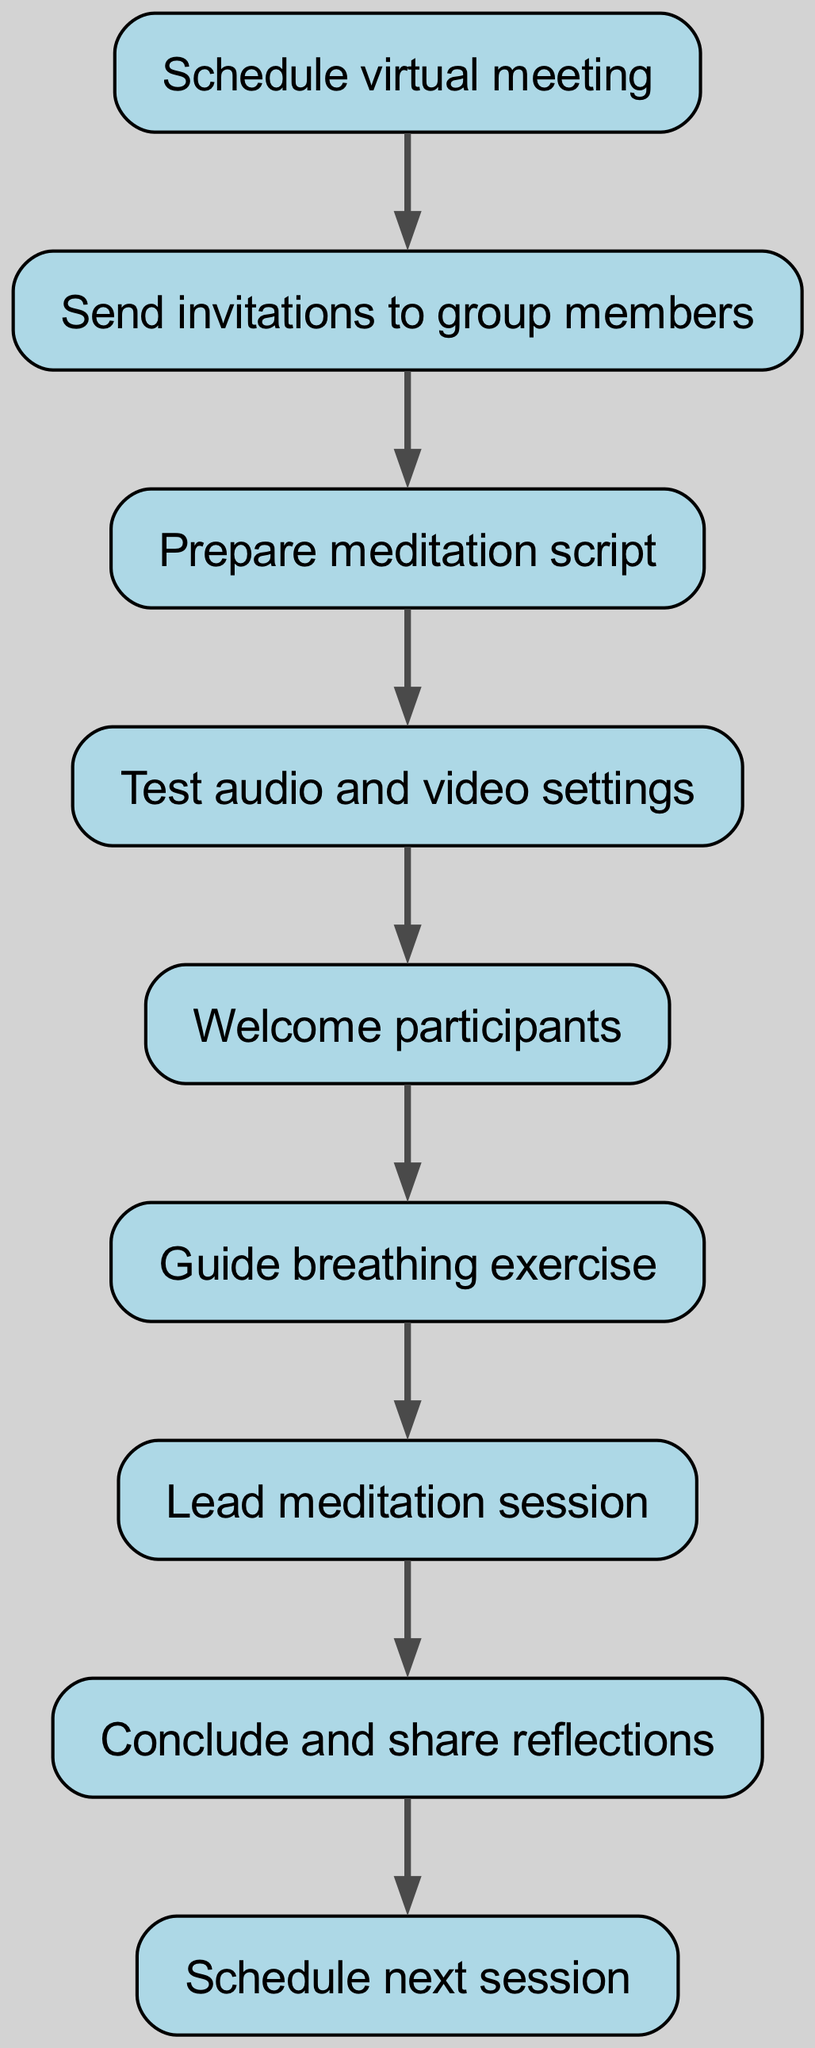What is the first step in the meditation process? The first step is to "Schedule virtual meeting". This is indicated as the starting node in the flow chart.
Answer: Schedule virtual meeting How many nodes are there in the diagram? By counting each unique step or element represented in the diagram, there are a total of 9 nodes present.
Answer: 9 Which step follows "Guide breathing exercise"? "Lead meditation session" is the next step after "Guide breathing exercise", as indicated by the direct connection from one node to the next.
Answer: Lead meditation session What is the last step of the meditation process? The last step is "Schedule next session", which does not have any outgoing connections indicating the process has concluded here.
Answer: Schedule next session Which steps are connected directly to "Prepare meditation script"? The direct connection indicates that "Send invitations to group members" leads to "Prepare meditation script", meaning it is the only step connected to it.
Answer: Send invitations to group members 